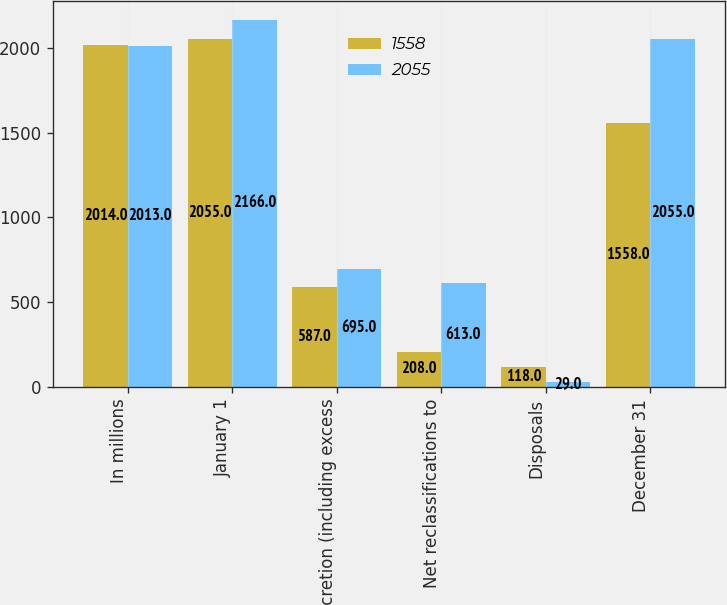Convert chart. <chart><loc_0><loc_0><loc_500><loc_500><stacked_bar_chart><ecel><fcel>In millions<fcel>January 1<fcel>Accretion (including excess<fcel>Net reclassifications to<fcel>Disposals<fcel>December 31<nl><fcel>1558<fcel>2014<fcel>2055<fcel>587<fcel>208<fcel>118<fcel>1558<nl><fcel>2055<fcel>2013<fcel>2166<fcel>695<fcel>613<fcel>29<fcel>2055<nl></chart> 